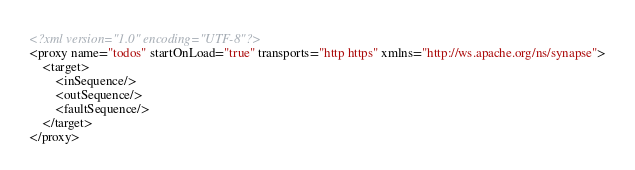Convert code to text. <code><loc_0><loc_0><loc_500><loc_500><_XML_><?xml version="1.0" encoding="UTF-8"?>
<proxy name="todos" startOnLoad="true" transports="http https" xmlns="http://ws.apache.org/ns/synapse">
    <target>
        <inSequence/>
        <outSequence/>
        <faultSequence/>
    </target>
</proxy>
</code> 